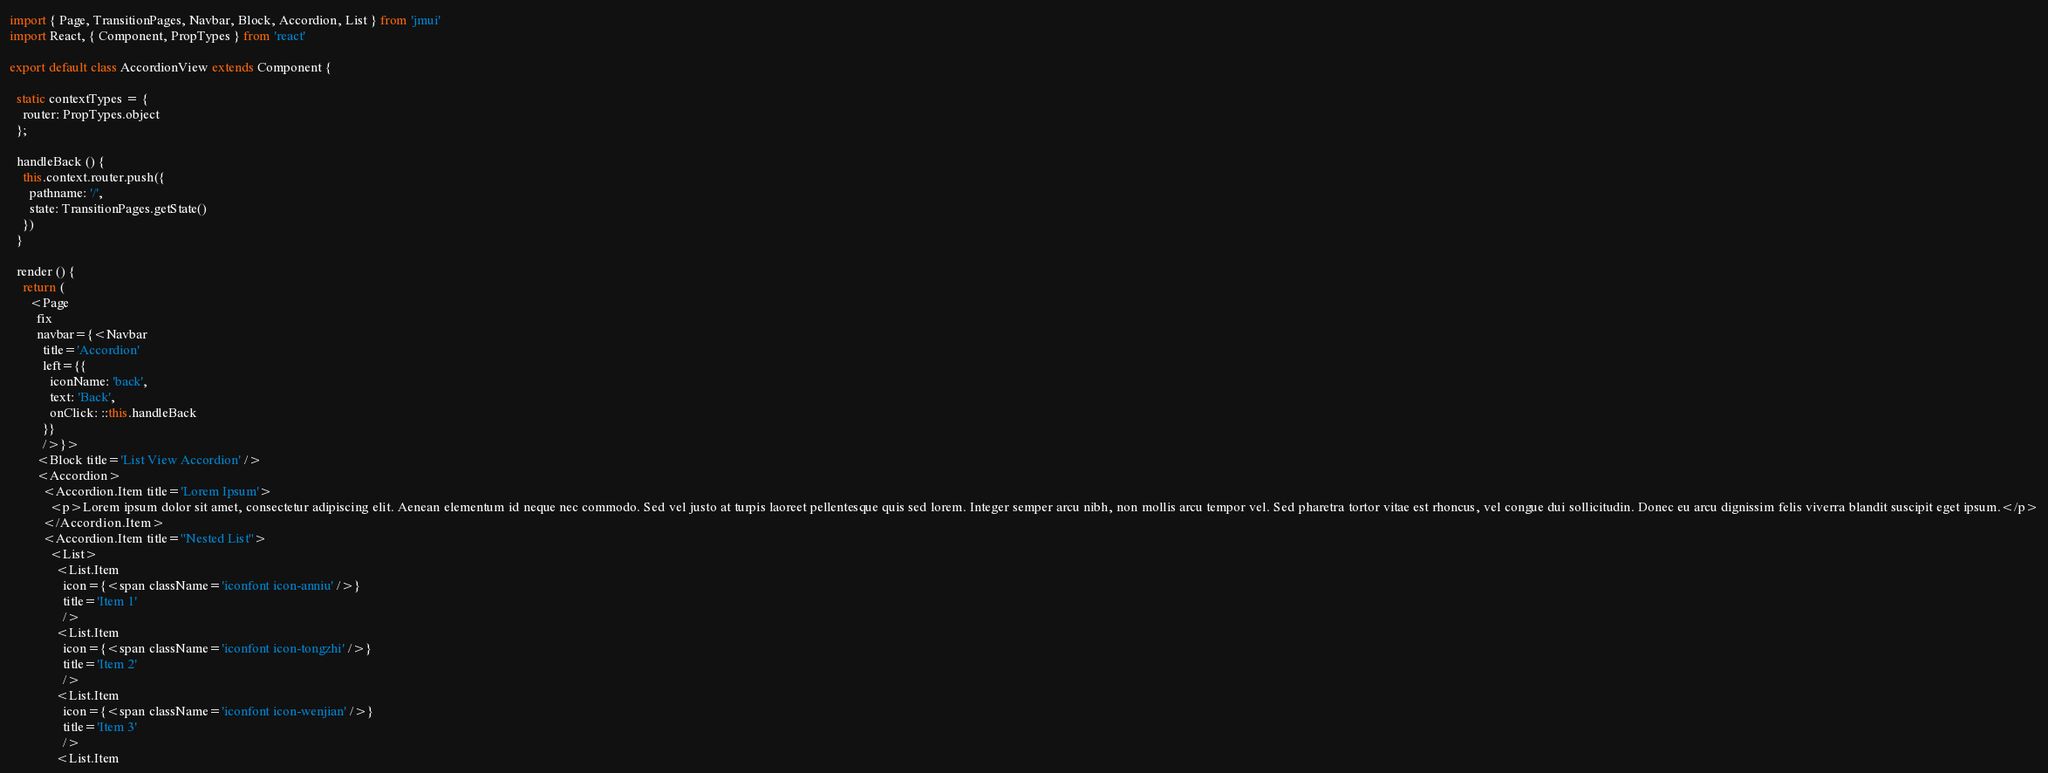Convert code to text. <code><loc_0><loc_0><loc_500><loc_500><_JavaScript_>import { Page, TransitionPages, Navbar, Block, Accordion, List } from 'jmui'
import React, { Component, PropTypes } from 'react'

export default class AccordionView extends Component {

  static contextTypes = {
    router: PropTypes.object
  };

  handleBack () {
    this.context.router.push({
      pathname: '/',
      state: TransitionPages.getState()
    })
  }

  render () {
    return (
      <Page
        fix
        navbar={<Navbar
          title='Accordion'
          left={{
            iconName: 'back',
            text: 'Back',
            onClick: ::this.handleBack
          }}
          />}>
        <Block title='List View Accordion' />
        <Accordion>
          <Accordion.Item title='Lorem Ipsum'>
            <p>Lorem ipsum dolor sit amet, consectetur adipiscing elit. Aenean elementum id neque nec commodo. Sed vel justo at turpis laoreet pellentesque quis sed lorem. Integer semper arcu nibh, non mollis arcu tempor vel. Sed pharetra tortor vitae est rhoncus, vel congue dui sollicitudin. Donec eu arcu dignissim felis viverra blandit suscipit eget ipsum.</p>
          </Accordion.Item>
          <Accordion.Item title="Nested List">
            <List>
              <List.Item
                icon={<span className='iconfont icon-anniu' />}
                title='Item 1'
                />
              <List.Item
                icon={<span className='iconfont icon-tongzhi' />}
                title='Item 2'
                />
              <List.Item
                icon={<span className='iconfont icon-wenjian' />}
                title='Item 3'
                />
              <List.Item</code> 